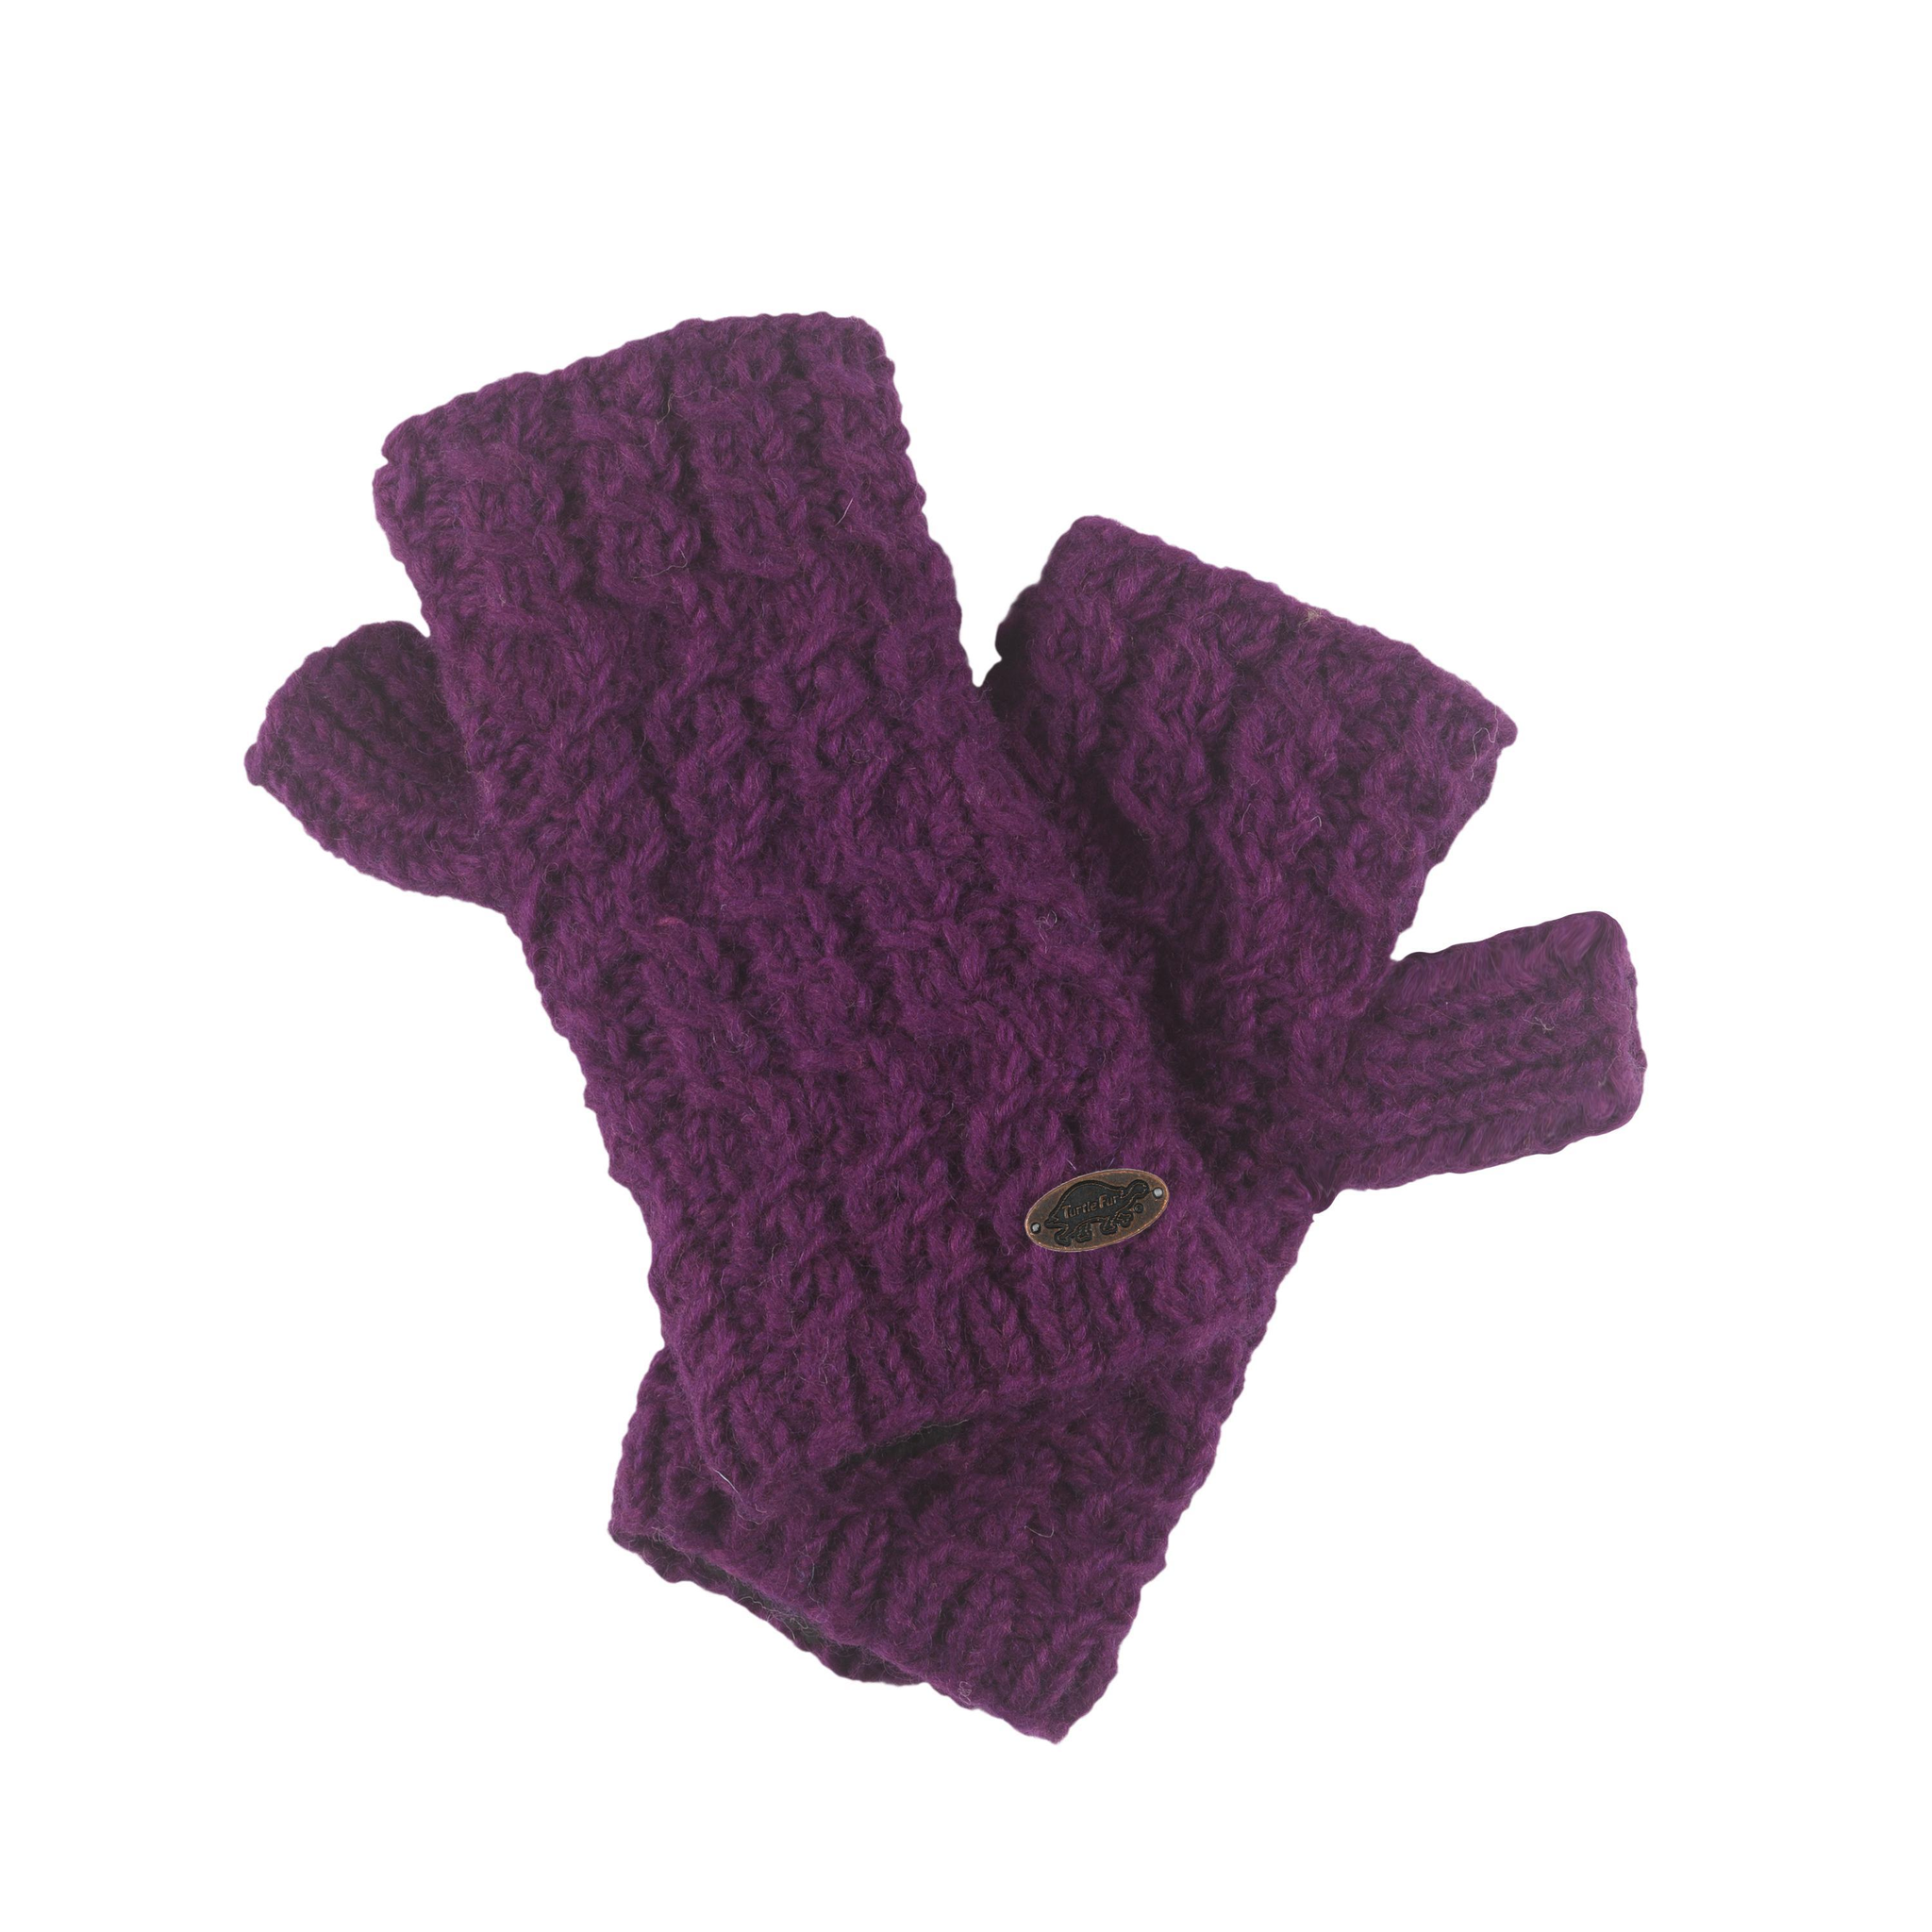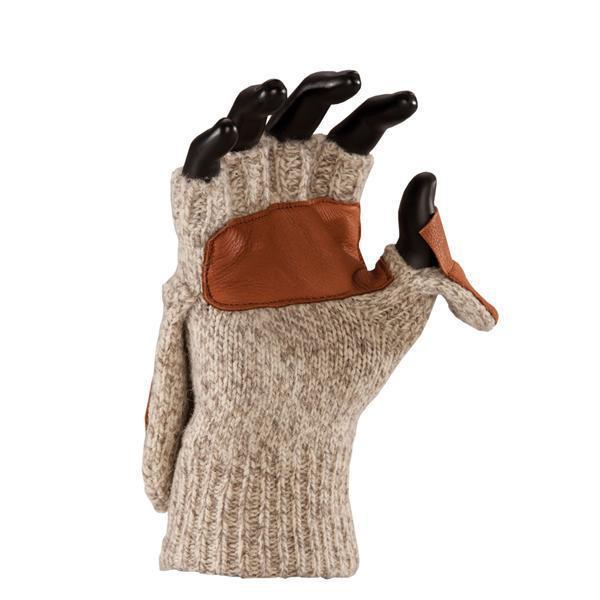The first image is the image on the left, the second image is the image on the right. Assess this claim about the two images: "a mannequin's hand is wearing a glove.". Correct or not? Answer yes or no. Yes. The first image is the image on the left, the second image is the image on the right. Assess this claim about the two images: "A fingerless glove in a taupe color with ribbed detailing in the wrist section is modeled in one image by a black hand mannequin.". Correct or not? Answer yes or no. Yes. 